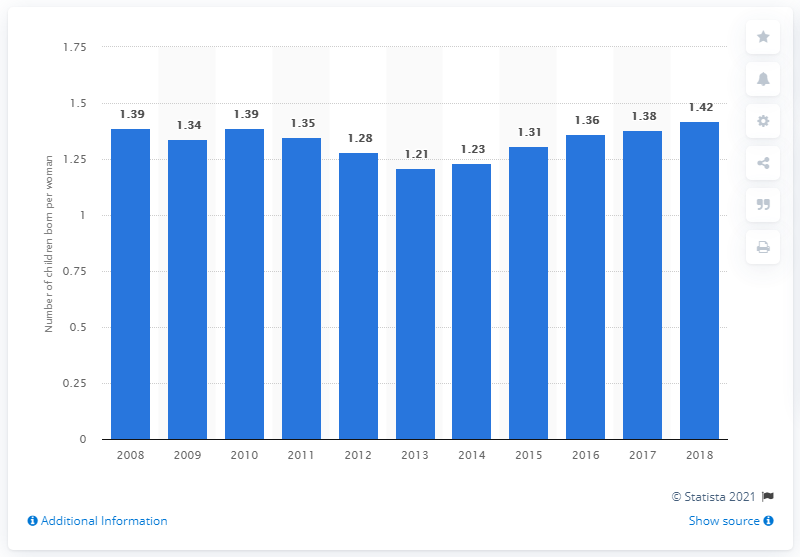What trend does the fertility rate in Portugal show over the past decade? The chart indicates that the fertility rate in Portugal experienced a downward trend from 2008 until around 2013, after which there seems to be a slight upward trend, culminating in a rate of 1.42 children per woman by 2018. Can we infer any economic or policy changes affecting this trend from the image? While the image exclusively displays the fertility rate data, it doesn't provide specific information on economic factors or policies. However, changes in fertility rates can often be influenced by a variety of factors including economic conditions, social policies, and access to family planning resources. 